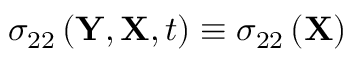Convert formula to latex. <formula><loc_0><loc_0><loc_500><loc_500>\sigma _ { 2 2 } \left ( Y , X , t \right ) \equiv \sigma _ { 2 2 } \left ( X \right )</formula> 